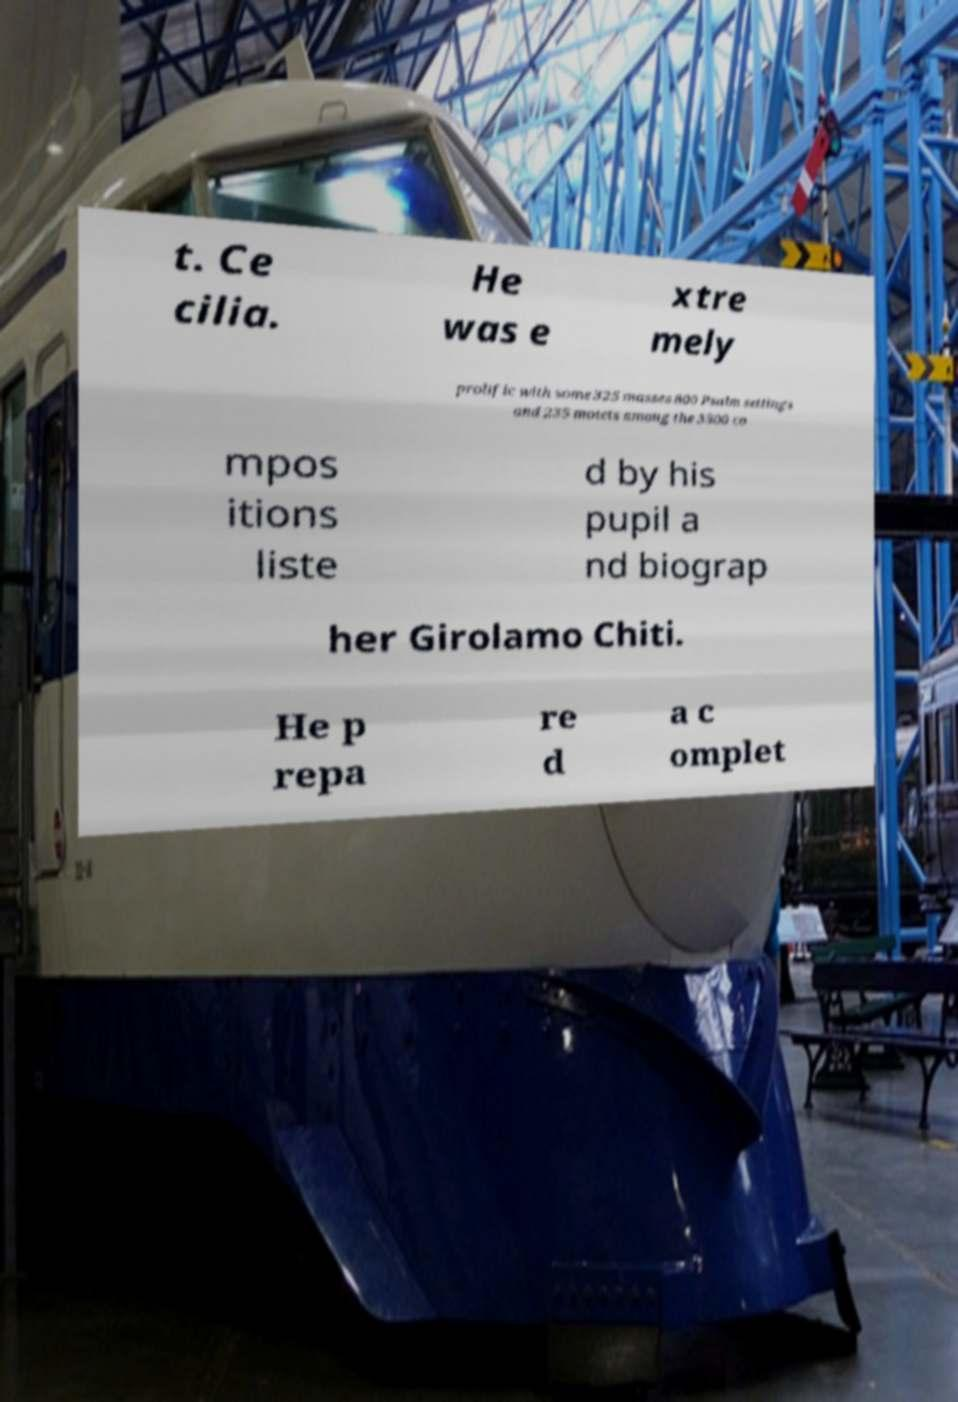Could you assist in decoding the text presented in this image and type it out clearly? t. Ce cilia. He was e xtre mely prolific with some 325 masses 800 Psalm settings and 235 motets among the 3500 co mpos itions liste d by his pupil a nd biograp her Girolamo Chiti. He p repa re d a c omplet 